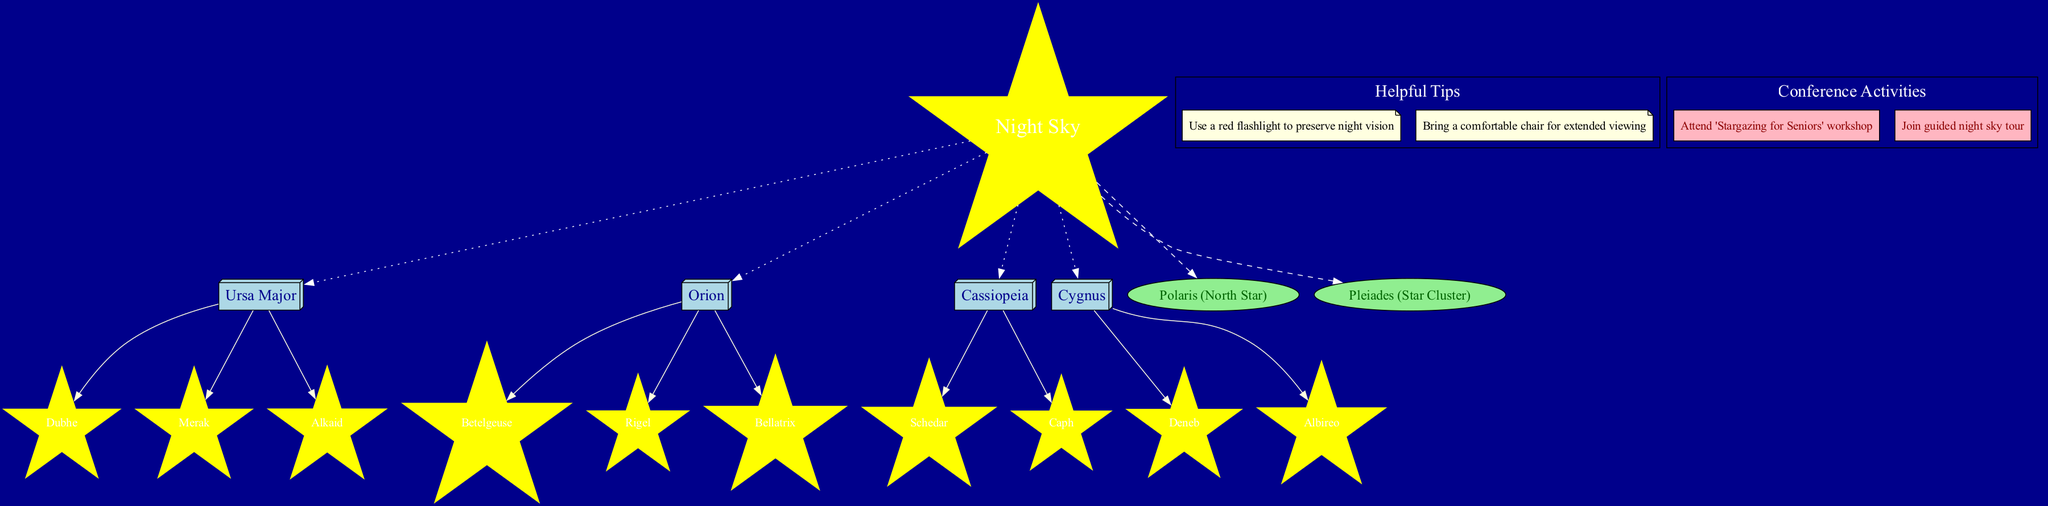What is the center node of the diagram? The center node is labeled as 'Night Sky'. This can be identified from the diagram as the central point from which all constellations and celestial objects are connected.
Answer: Night Sky How many constellations are shown in the diagram? The diagram displays four constellations: Ursa Major, Orion, Cassiopeia, and Cygnus. This is determined by counting the individual nodes that represent each constellation.
Answer: 4 Which star is connected to Ursa Major? The stars connected to Ursa Major, as represented in the diagram, are Dubhe, Merak, and Alkaid. This can be confirmed by looking at the stars branching from the Ursa Major node.
Answer: Dubhe, Merak, Alkaid What type of shape is used to represent celestial objects? Celestial objects such as Polaris and Pleiades are represented using an oval shape. This is distinctive since it differentiates them from the box shapes used for constellations.
Answer: Oval How many helpful tips are included in the diagram? The diagram includes two helpful tips, which can be identified within the section labeled 'Helpful Tips'. Each tip is listed in the subgraph, and direct counting confirms the total.
Answer: 2 Which constellation has the star Betelgeuse? Betelgeuse is associated with the constellation Orion. This relationship is established by tracing the connection from the star to its respective constellation node.
Answer: Orion What color are the stars labeled in the diagram? The stars are colored yellow, which can be seen in their shape, confirming their category as stars in this astronomy diagram.
Answer: Yellow Which conference-related activity mentions stargazing? The activity 'Stargazing for Seniors' workshop clearly mentions stargazing in its title, which is located in the conference information section of the diagram.
Answer: Stargazing for Seniors' workshop Name a star cluster shown in the diagram. The diagram lists 'Pleiades (Star Cluster)' among the celestial objects, indicating that it is recognized as a star cluster in astronomy.
Answer: Pleiades 